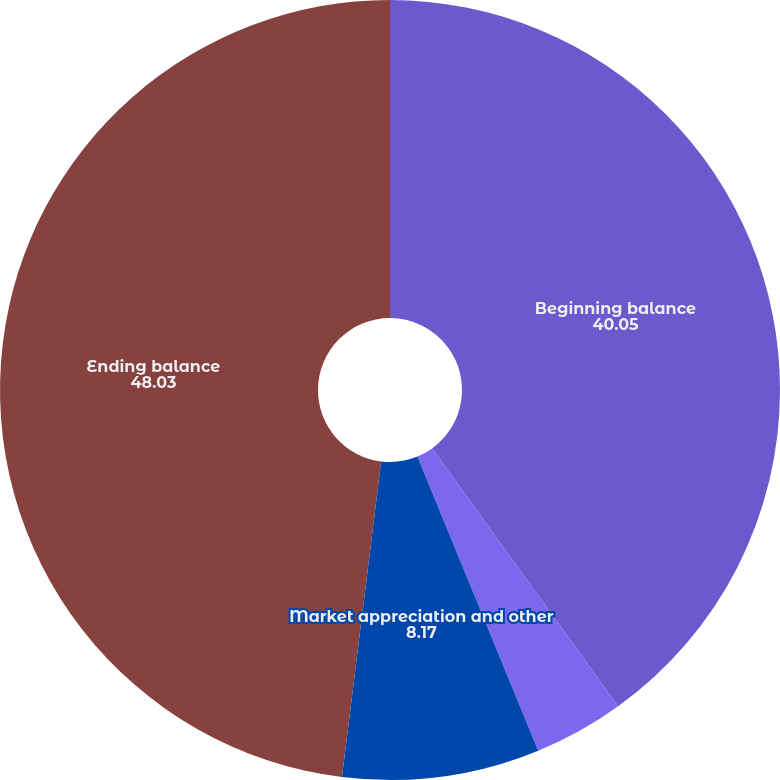Convert chart. <chart><loc_0><loc_0><loc_500><loc_500><pie_chart><fcel>Beginning balance<fcel>Net flows<fcel>Market appreciation and other<fcel>Ending balance<nl><fcel>40.05%<fcel>3.74%<fcel>8.17%<fcel>48.03%<nl></chart> 